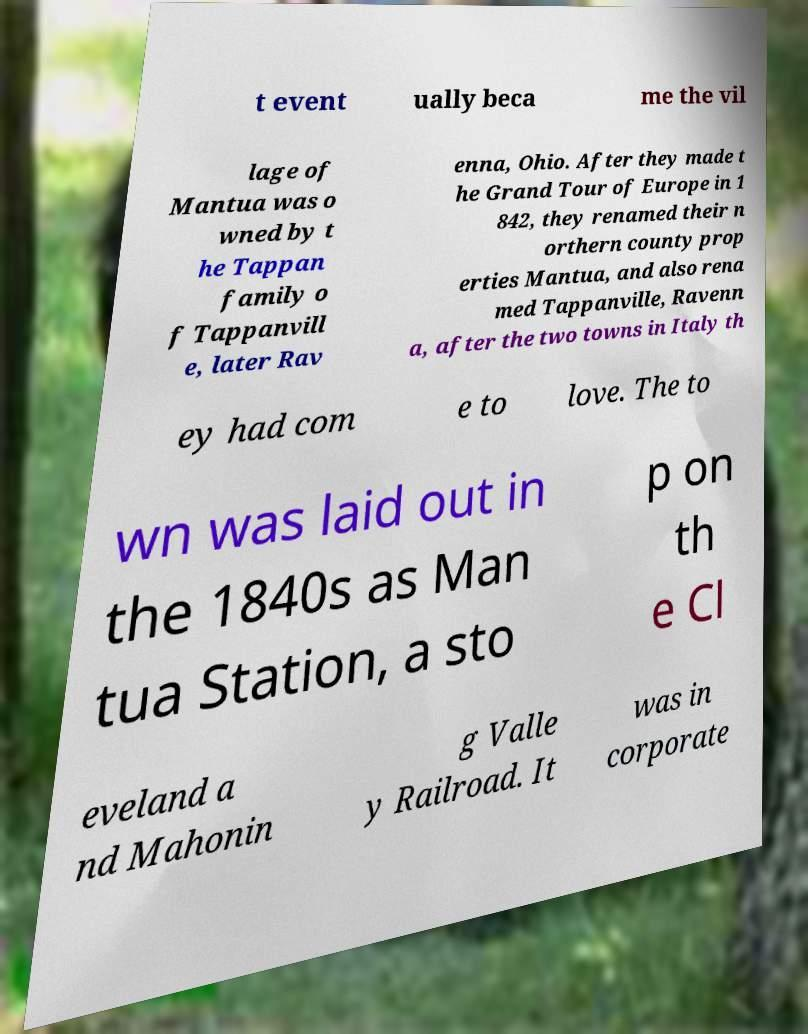Could you assist in decoding the text presented in this image and type it out clearly? t event ually beca me the vil lage of Mantua was o wned by t he Tappan family o f Tappanvill e, later Rav enna, Ohio. After they made t he Grand Tour of Europe in 1 842, they renamed their n orthern county prop erties Mantua, and also rena med Tappanville, Ravenn a, after the two towns in Italy th ey had com e to love. The to wn was laid out in the 1840s as Man tua Station, a sto p on th e Cl eveland a nd Mahonin g Valle y Railroad. It was in corporate 